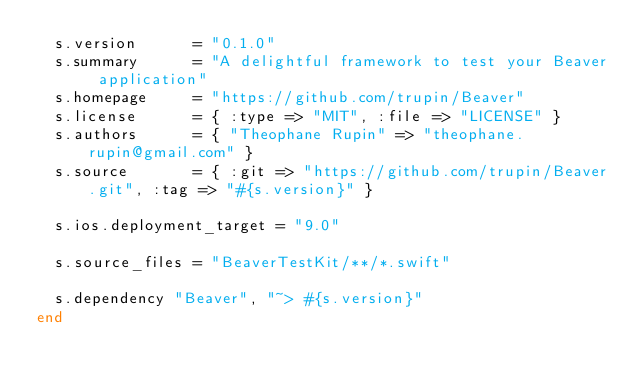<code> <loc_0><loc_0><loc_500><loc_500><_Ruby_>  s.version      = "0.1.0"
  s.summary      = "A delightful framework to test your Beaver application"
  s.homepage     = "https://github.com/trupin/Beaver"
  s.license      = { :type => "MIT", :file => "LICENSE" }
  s.authors      = { "Theophane Rupin" => "theophane.rupin@gmail.com" }
  s.source       = { :git => "https://github.com/trupin/Beaver.git", :tag => "#{s.version}" }

  s.ios.deployment_target = "9.0"

  s.source_files = "BeaverTestKit/**/*.swift"

  s.dependency "Beaver", "~> #{s.version}"
end</code> 